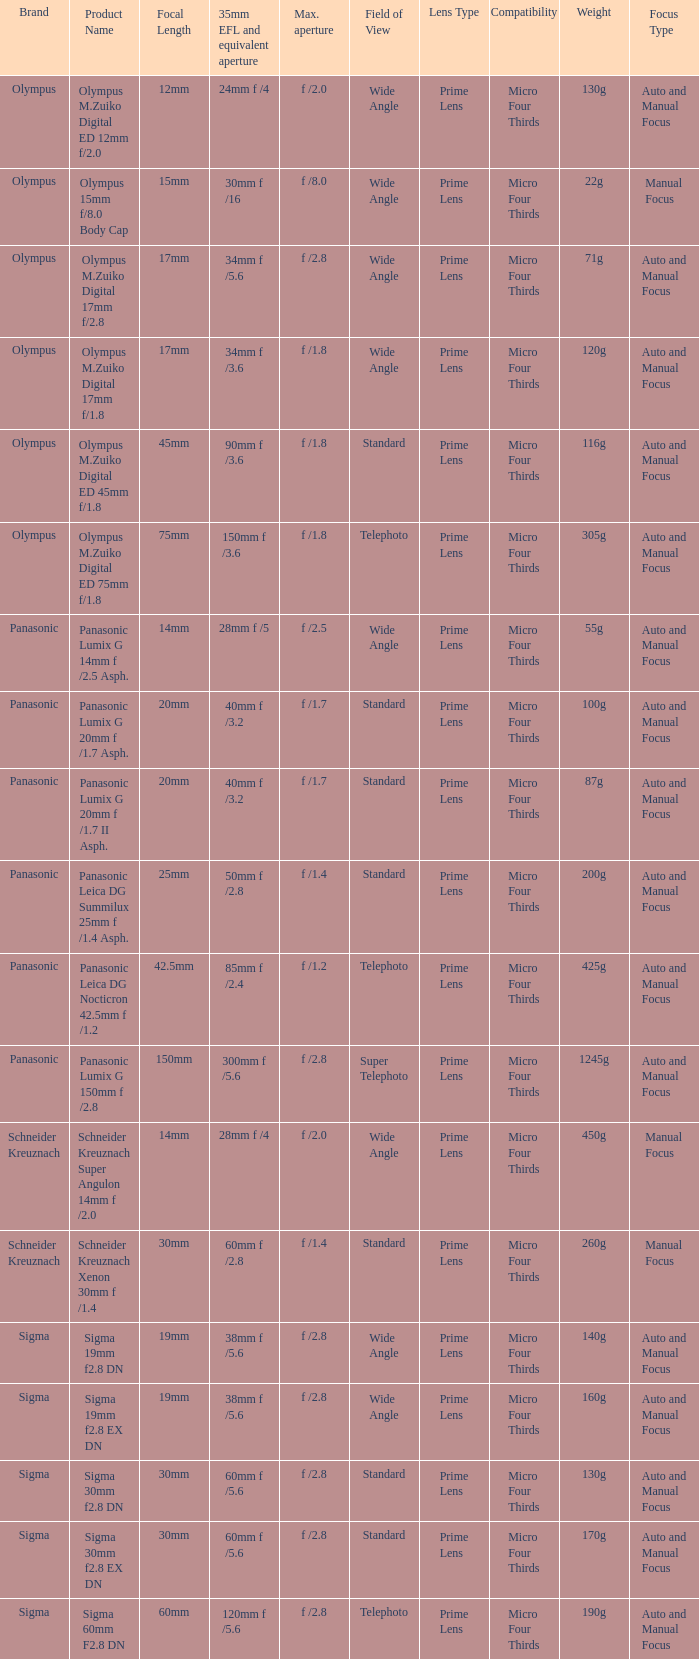What is the maximum aperture of the lens(es) with a focal length of 20mm? F /1.7, f /1.7. Would you be able to parse every entry in this table? {'header': ['Brand', 'Product Name', 'Focal Length', '35mm EFL and equivalent aperture', 'Max. aperture', 'Field of View', 'Lens Type', 'Compatibility', 'Weight', 'Focus Type'], 'rows': [['Olympus', 'Olympus M.Zuiko Digital ED 12mm f/2.0', '12mm', '24mm f /4', 'f /2.0', 'Wide Angle', 'Prime Lens', 'Micro Four Thirds', '130g', 'Auto and Manual Focus'], ['Olympus', 'Olympus 15mm f/8.0 Body Cap', '15mm', '30mm f /16', 'f /8.0', 'Wide Angle', 'Prime Lens', 'Micro Four Thirds', '22g', 'Manual Focus'], ['Olympus', 'Olympus M.Zuiko Digital 17mm f/2.8', '17mm', '34mm f /5.6', 'f /2.8', 'Wide Angle', 'Prime Lens', 'Micro Four Thirds', '71g', 'Auto and Manual Focus'], ['Olympus', 'Olympus M.Zuiko Digital 17mm f/1.8', '17mm', '34mm f /3.6', 'f /1.8', 'Wide Angle', 'Prime Lens', 'Micro Four Thirds', '120g', 'Auto and Manual Focus '], ['Olympus', 'Olympus M.Zuiko Digital ED 45mm f/1.8', '45mm', '90mm f /3.6', 'f /1.8', 'Standard', 'Prime Lens', 'Micro Four Thirds', '116g', 'Auto and Manual Focus'], ['Olympus', 'Olympus M.Zuiko Digital ED 75mm f/1.8', '75mm', '150mm f /3.6', 'f /1.8', 'Telephoto', 'Prime Lens', 'Micro Four Thirds', '305g', 'Auto and Manual Focus'], ['Panasonic', 'Panasonic Lumix G 14mm f /2.5 Asph.', '14mm', '28mm f /5', 'f /2.5', 'Wide Angle', 'Prime Lens', 'Micro Four Thirds', '55g', 'Auto and Manual Focus'], ['Panasonic', 'Panasonic Lumix G 20mm f /1.7 Asph.', '20mm', '40mm f /3.2', 'f /1.7', 'Standard', 'Prime Lens', 'Micro Four Thirds', '100g', 'Auto and Manual Focus'], ['Panasonic', 'Panasonic Lumix G 20mm f /1.7 II Asph.', '20mm', '40mm f /3.2', 'f /1.7', 'Standard', 'Prime Lens', 'Micro Four Thirds', '87g', 'Auto and Manual Focus'], ['Panasonic', 'Panasonic Leica DG Summilux 25mm f /1.4 Asph.', '25mm', '50mm f /2.8', 'f /1.4', 'Standard', 'Prime Lens', 'Micro Four Thirds', '200g', 'Auto and Manual Focus'], ['Panasonic', 'Panasonic Leica DG Nocticron 42.5mm f /1.2', '42.5mm', '85mm f /2.4', 'f /1.2', 'Telephoto', 'Prime Lens', 'Micro Four Thirds', '425g', 'Auto and Manual Focus'], ['Panasonic', 'Panasonic Lumix G 150mm f /2.8', '150mm', '300mm f /5.6', 'f /2.8', 'Super Telephoto', 'Prime Lens', 'Micro Four Thirds', '1245g', 'Auto and Manual Focus'], ['Schneider Kreuznach', 'Schneider Kreuznach Super Angulon 14mm f /2.0', '14mm', '28mm f /4', 'f /2.0', 'Wide Angle', 'Prime Lens', 'Micro Four Thirds', '450g', 'Manual Focus'], ['Schneider Kreuznach', 'Schneider Kreuznach Xenon 30mm f /1.4', '30mm', '60mm f /2.8', 'f /1.4', 'Standard', 'Prime Lens', 'Micro Four Thirds', '260g', 'Manual Focus'], ['Sigma', 'Sigma 19mm f2.8 DN', '19mm', '38mm f /5.6', 'f /2.8', 'Wide Angle', 'Prime Lens', 'Micro Four Thirds', '140g', 'Auto and Manual Focus'], ['Sigma', 'Sigma 19mm f2.8 EX DN', '19mm', '38mm f /5.6', 'f /2.8', 'Wide Angle', 'Prime Lens', 'Micro Four Thirds', '160g', 'Auto and Manual Focus'], ['Sigma', 'Sigma 30mm f2.8 DN', '30mm', '60mm f /5.6', 'f /2.8', 'Standard', 'Prime Lens', 'Micro Four Thirds', '130g', 'Auto and Manual Focus'], ['Sigma', 'Sigma 30mm f2.8 EX DN', '30mm', '60mm f /5.6', 'f /2.8', 'Standard', 'Prime Lens', 'Micro Four Thirds', '170g', 'Auto and Manual Focus'], ['Sigma', 'Sigma 60mm F2.8 DN', '60mm', '120mm f /5.6', 'f /2.8', 'Telephoto', 'Prime Lens', 'Micro Four Thirds', '190g', 'Auto and Manual Focus']]} 